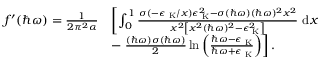Convert formula to latex. <formula><loc_0><loc_0><loc_500><loc_500>\begin{array} { r l } { f ^ { \prime } ( \hbar { \omega } ) = \frac { 1 } { 2 \pi ^ { 2 } \alpha } } & { \left [ \int _ { 0 } ^ { 1 } \frac { \sigma ( - \epsilon _ { K } / x ) \epsilon _ { K } ^ { 2 } - \sigma ( \hbar { \omega } ) ( \hbar { \omega } ) ^ { 2 } x ^ { 2 } } { x ^ { 2 } \left [ x ^ { 2 } ( \hbar { \omega } ) ^ { 2 } - \epsilon _ { K } ^ { 2 } \right ] } d x } \\ & { - \frac { ( \hbar { \omega } ) \sigma ( \hbar { \omega } ) } { 2 } \ln { \left ( \frac { \hbar { \omega } - \epsilon _ { K } } { \hbar { \omega } + \epsilon _ { K } } \right ) } \right ] . } \end{array}</formula> 